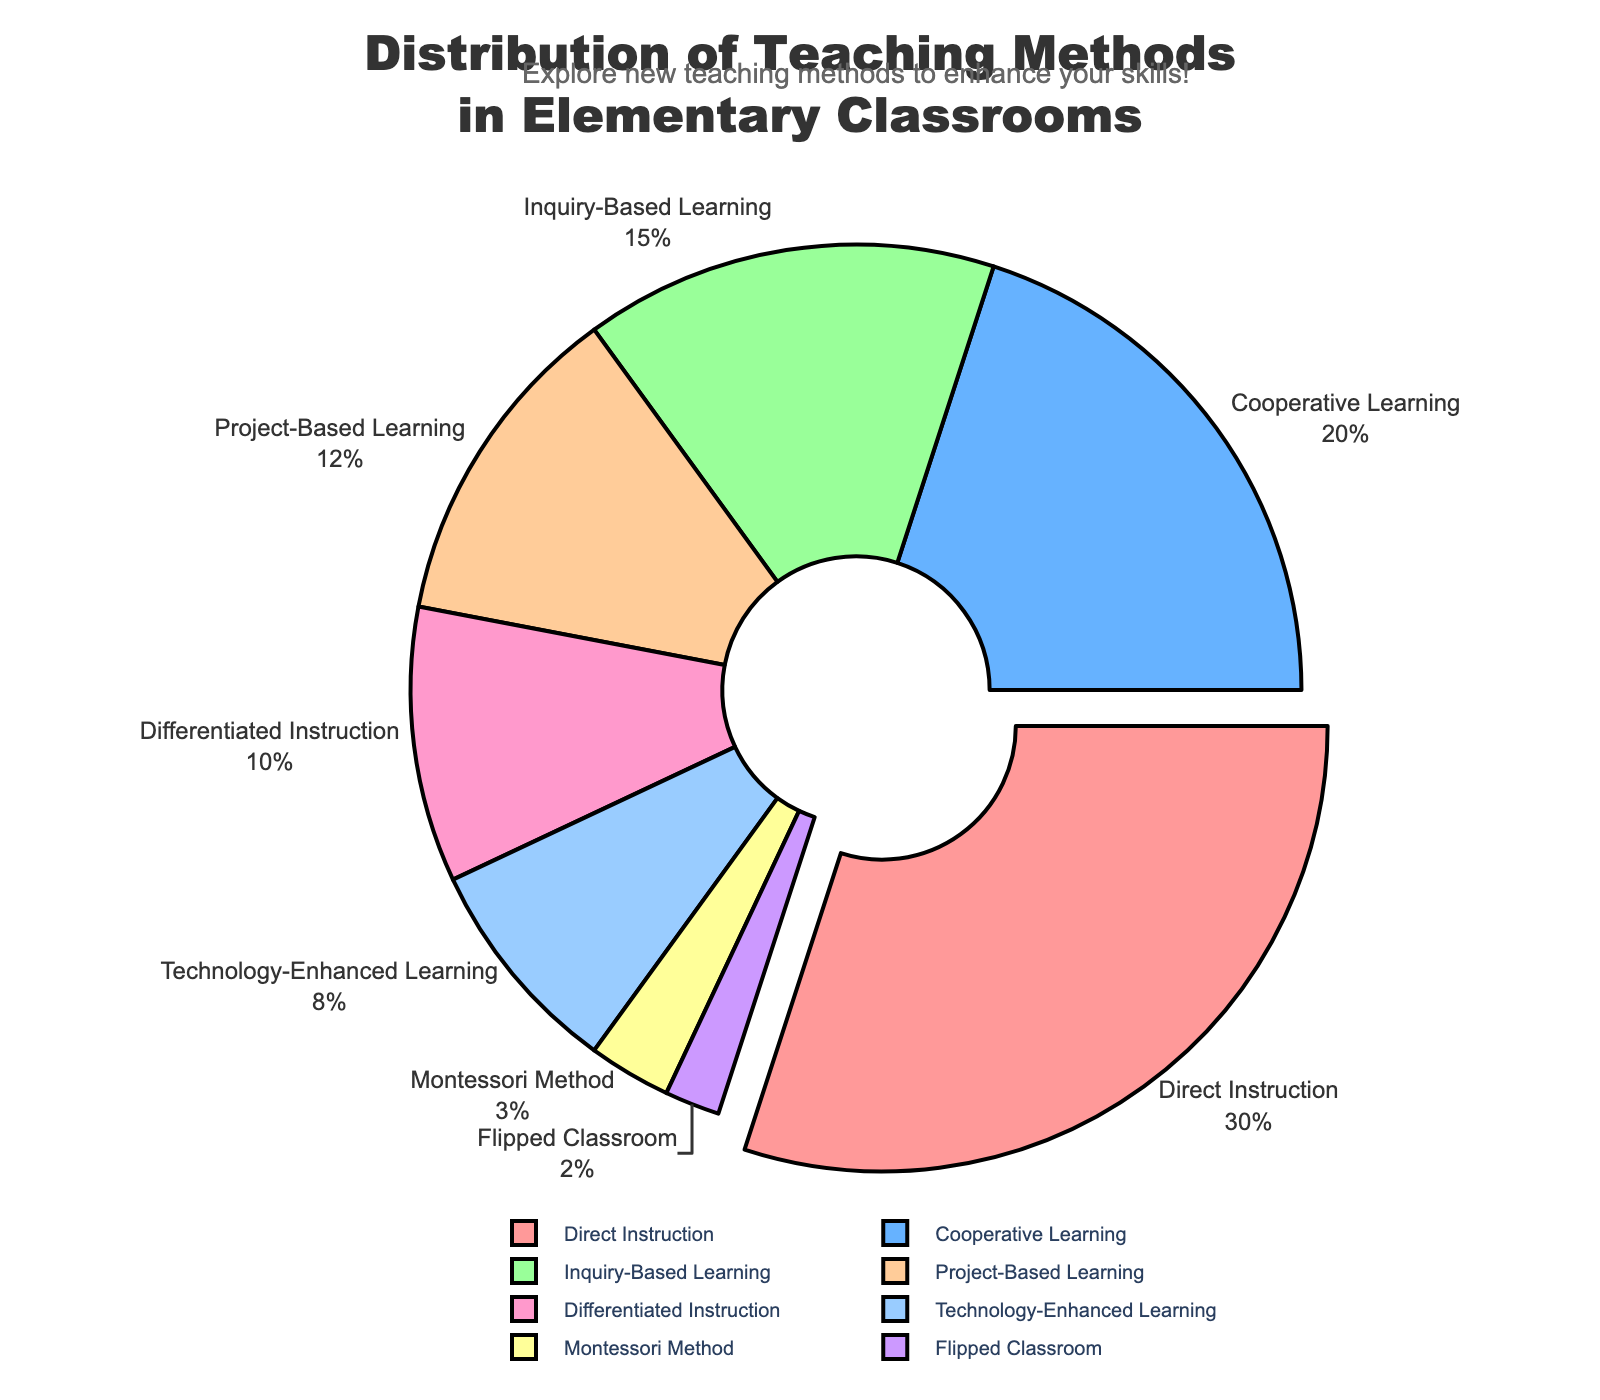What's the most commonly used teaching method in elementary classrooms? According to the pie chart, the largest segment represents Direct Instruction, which is 30%.
Answer: Direct Instruction Which teaching method is used more: Project-Based Learning or Cooperative Learning? As shown in the chart, Project-Based Learning is at 12% and Cooperative Learning is at 20%. 20% is greater than 12%.
Answer: Cooperative Learning What is the combined percentage of Inquiry-Based Learning and Technology-Enhanced Learning? Inquiry-Based Learning is 15% and Technology-Enhanced Learning is 8%. Adding these together gives 15% + 8% = 23%.
Answer: 23% Which teaching method has the smallest percentage in the distribution, and what is that percentage? The smallest segment in the pie chart is for the Flipped Classroom, which occupies 2% of the chart.
Answer: Flipped Classroom, 2% How much more prevalent is Direct Instruction compared to Differentiated Instruction? Direct Instruction is at 30%, and Differentiated Instruction is at 10%. The difference is 30% - 10% = 20%.
Answer: 20% If you combine Project-Based Learning, Differentiated Instruction, and Montessori Method, what would their total percentage be? Project-Based Learning has 12%, Differentiated Instruction has 10%, and Montessori Method has 3%. Adding them together gives 12% + 10% + 3% = 25%.
Answer: 25% What percentage of teaching methods are used less commonly than Inquiry-Based Learning? The percentages lower than Inquiry-Based Learning (15%) are Project-Based Learning (12%), Differentiated Instruction (10%), Technology-Enhanced Learning (8%), Montessori Method (3%), and Flipped Classroom (2%). Adding these together, 12% + 10% + 8% + 3% + 2% = 35%.
Answer: 35% Which teaching method is represented by the green segment, and what percentage does it have? The pie chart color scheme indicates that the green segment corresponds to Inquiry-Based Learning, which is 15%.
Answer: Inquiry-Based Learning, 15% What is the sum of the percentages of all the teaching methods displayed in the pie chart? Summing all given percentages: 30% + 20% + 15% + 12% + 10% + 8% + 3% + 2% = 100%.
Answer: 100% Among the methods with less than 10% usage, which one has the highest percentage? The methods with less than 10% usage are Technology-Enhanced Learning (8%), Montessori Method (3%), and Flipped Classroom (2%). The highest among these is Technology-Enhanced Learning at 8%.
Answer: Technology-Enhanced Learning 